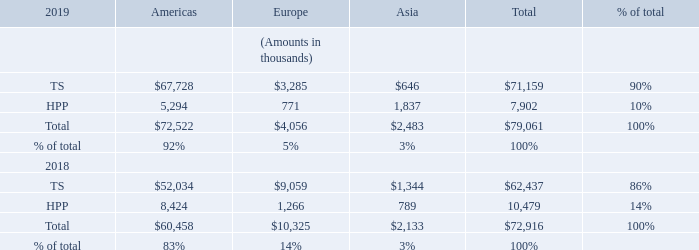The following table details the Company’s sales by operating segment for fiscal years ended September 30, 2019 and 2018. The Company’s sales by geographic area based on the location of where the products were shipped or services rendered are as follows:
Substantially all Americas amounts are United States.
How does the company sort its sales by? Geographic area. How does the company determine its sales by geographic area? Based on the location of where the products were shipped or services rendered. What percentage of the company's 2019 sales are from Asia? 3%. What is the percentage change in Asia sales between 2018 and 2019?
Answer scale should be: percent. (2,483 - 2,133)/2,133 
Answer: 16.41. What is the difference in total sales between 2018 and 2019?
Answer scale should be: thousand. 79,061 - 72,916 
Answer: 6145. What is the difference in total sales between TS Asia and TS Europe in 2019?
Answer scale should be: thousand. 3,285-646 
Answer: 2639. 